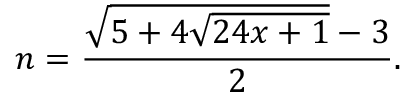Convert formula to latex. <formula><loc_0><loc_0><loc_500><loc_500>n = { \frac { { \sqrt { 5 + 4 { \sqrt { 2 4 x + 1 } } } } - 3 } { 2 } } .</formula> 